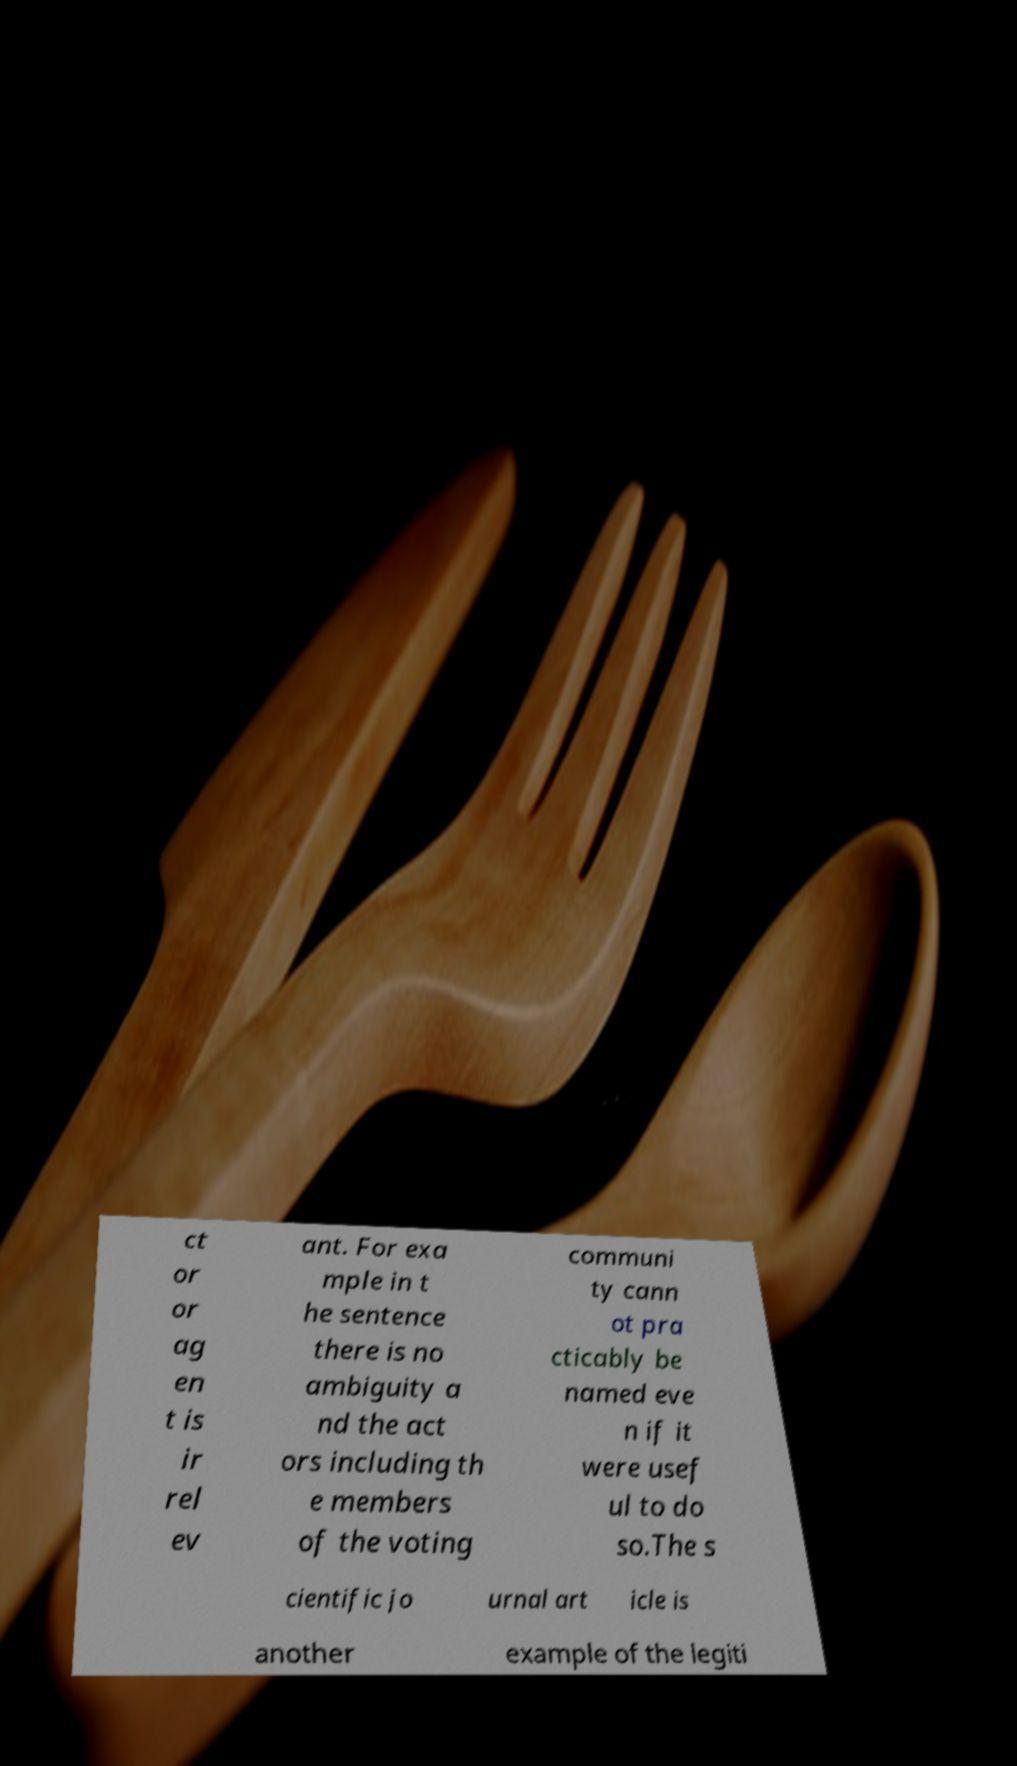Could you extract and type out the text from this image? ct or or ag en t is ir rel ev ant. For exa mple in t he sentence there is no ambiguity a nd the act ors including th e members of the voting communi ty cann ot pra cticably be named eve n if it were usef ul to do so.The s cientific jo urnal art icle is another example of the legiti 